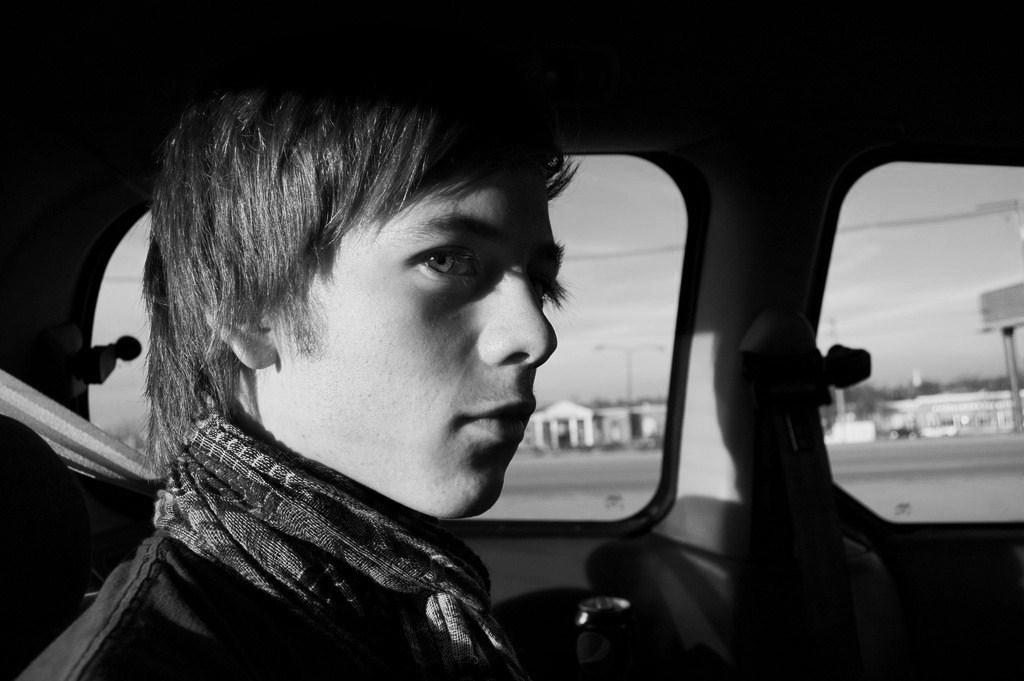Who is present in the image? There is a person in the image. What is the person doing in the image? The person is sitting in a car. What type of zephyr is the person holding in the image? There is no zephyr present in the image; it is a person sitting in a car. What type of insurance does the person have for the car in the image? The image does not provide information about the person's insurance for the car. 